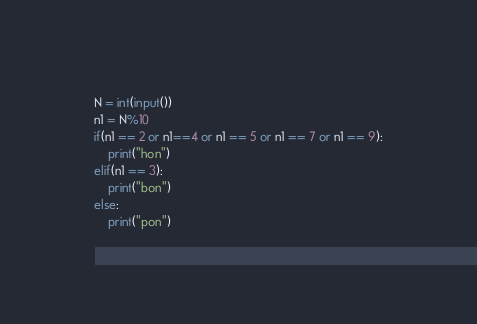Convert code to text. <code><loc_0><loc_0><loc_500><loc_500><_Python_>N = int(input())
n1 = N%10
if(n1 == 2 or n1==4 or n1 == 5 or n1 == 7 or n1 == 9):
    print("hon")
elif(n1 == 3):
    print("bon")
else:
    print("pon")</code> 